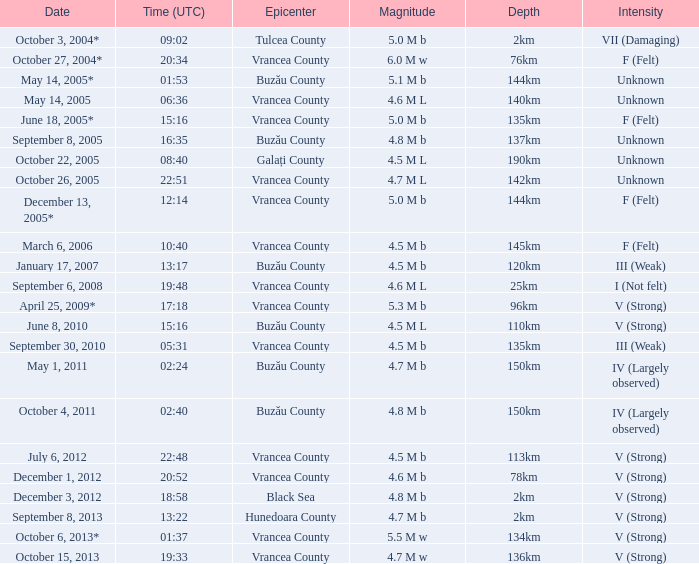Could you parse the entire table? {'header': ['Date', 'Time (UTC)', 'Epicenter', 'Magnitude', 'Depth', 'Intensity'], 'rows': [['October 3, 2004*', '09:02', 'Tulcea County', '5.0 M b', '2km', 'VII (Damaging)'], ['October 27, 2004*', '20:34', 'Vrancea County', '6.0 M w', '76km', 'F (Felt)'], ['May 14, 2005*', '01:53', 'Buzău County', '5.1 M b', '144km', 'Unknown'], ['May 14, 2005', '06:36', 'Vrancea County', '4.6 M L', '140km', 'Unknown'], ['June 18, 2005*', '15:16', 'Vrancea County', '5.0 M b', '135km', 'F (Felt)'], ['September 8, 2005', '16:35', 'Buzău County', '4.8 M b', '137km', 'Unknown'], ['October 22, 2005', '08:40', 'Galați County', '4.5 M L', '190km', 'Unknown'], ['October 26, 2005', '22:51', 'Vrancea County', '4.7 M L', '142km', 'Unknown'], ['December 13, 2005*', '12:14', 'Vrancea County', '5.0 M b', '144km', 'F (Felt)'], ['March 6, 2006', '10:40', 'Vrancea County', '4.5 M b', '145km', 'F (Felt)'], ['January 17, 2007', '13:17', 'Buzău County', '4.5 M b', '120km', 'III (Weak)'], ['September 6, 2008', '19:48', 'Vrancea County', '4.6 M L', '25km', 'I (Not felt)'], ['April 25, 2009*', '17:18', 'Vrancea County', '5.3 M b', '96km', 'V (Strong)'], ['June 8, 2010', '15:16', 'Buzău County', '4.5 M L', '110km', 'V (Strong)'], ['September 30, 2010', '05:31', 'Vrancea County', '4.5 M b', '135km', 'III (Weak)'], ['May 1, 2011', '02:24', 'Buzău County', '4.7 M b', '150km', 'IV (Largely observed)'], ['October 4, 2011', '02:40', 'Buzău County', '4.8 M b', '150km', 'IV (Largely observed)'], ['July 6, 2012', '22:48', 'Vrancea County', '4.5 M b', '113km', 'V (Strong)'], ['December 1, 2012', '20:52', 'Vrancea County', '4.6 M b', '78km', 'V (Strong)'], ['December 3, 2012', '18:58', 'Black Sea', '4.8 M b', '2km', 'V (Strong)'], ['September 8, 2013', '13:22', 'Hunedoara County', '4.7 M b', '2km', 'V (Strong)'], ['October 6, 2013*', '01:37', 'Vrancea County', '5.5 M w', '134km', 'V (Strong)'], ['October 15, 2013', '19:33', 'Vrancea County', '4.7 M w', '136km', 'V (Strong)']]} Where was the central point of the tremor on december 1, 2012? Vrancea County. 